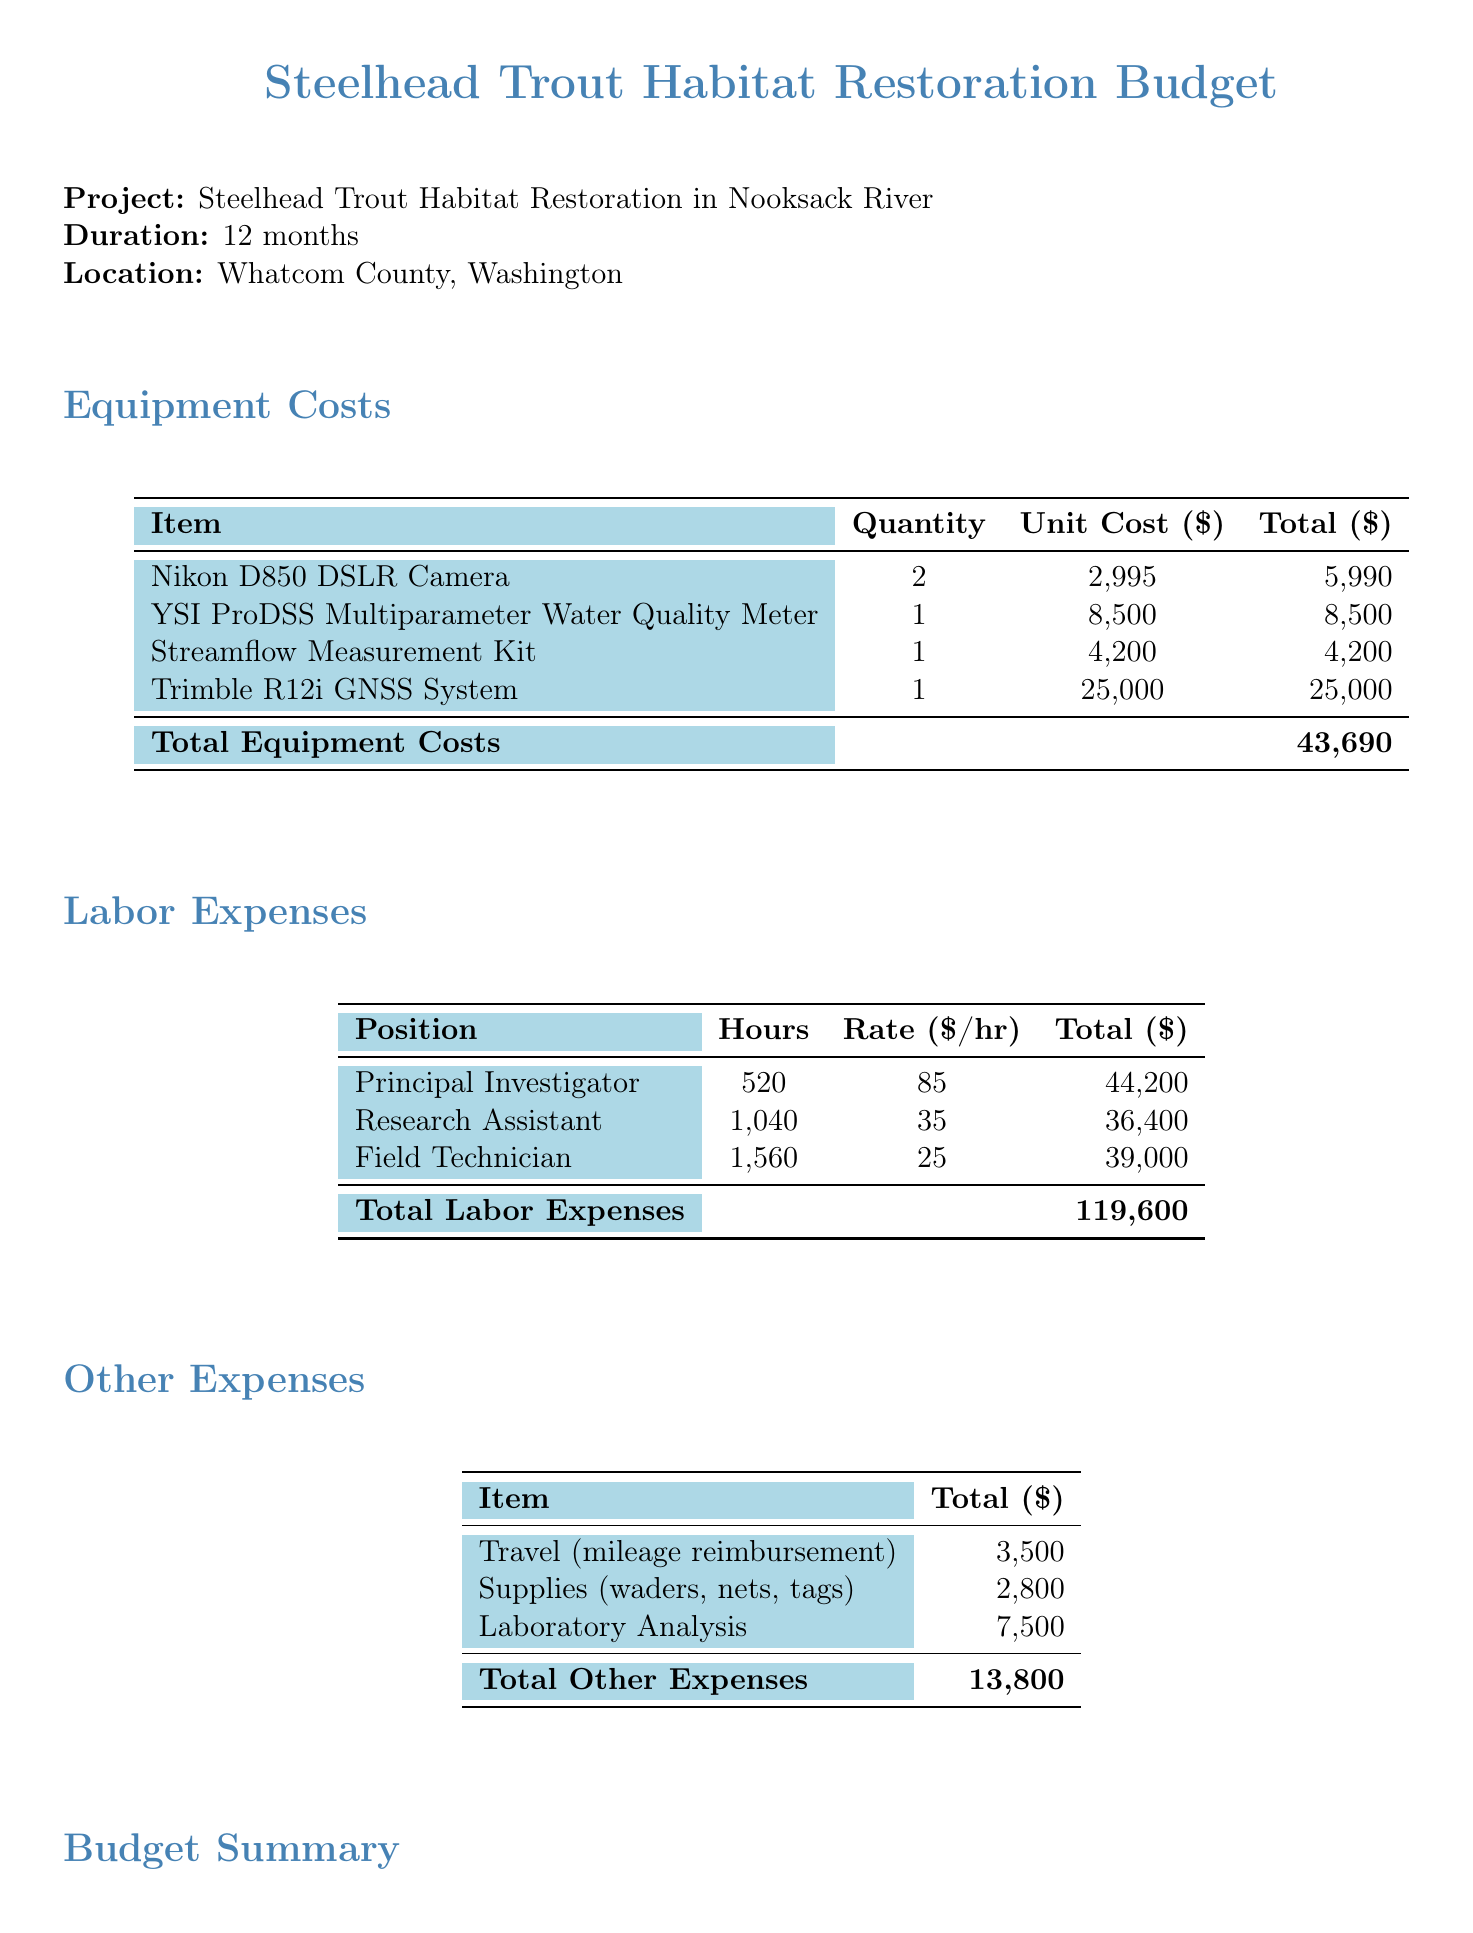what is the total equipment cost? The total equipment cost is shown in the budget summary section of the document as $43,690.
Answer: $43,690 how many hours did the field technician work? The document specifies the number of hours worked by the field technician, which is detailed in the labor expenses table.
Answer: 1560 what is the rate per hour for the principal investigator? The labor expenses table lists the rate for the principal investigator, providing the necessary information.
Answer: 85 what is the total project budget? The total project budget is clearly outlined in the budget summary section, combining all costs.
Answer: $221,363 how much is allocated for travel expenses? The document states that travel expenses total $3,500 within the other expenses section.
Answer: $3,500 what type of camera is included in the equipment costs? The equipment costs section mentions the specific camera model used for the project.
Answer: Nikon D850 DSLR Camera how much will be paid to the research assistant? The total payment for the research assistant can be found in the labor expenses table, which lists their total compensation.
Answer: $36,400 what percentage of the total direct costs represents indirect costs? The document specifies that indirect costs are calculated as 25% of the total direct costs in the budget summary.
Answer: 25% what is the location of the habitat restoration project? The location of the project is mentioned at the beginning of the document.
Answer: Whatcom County, Washington 